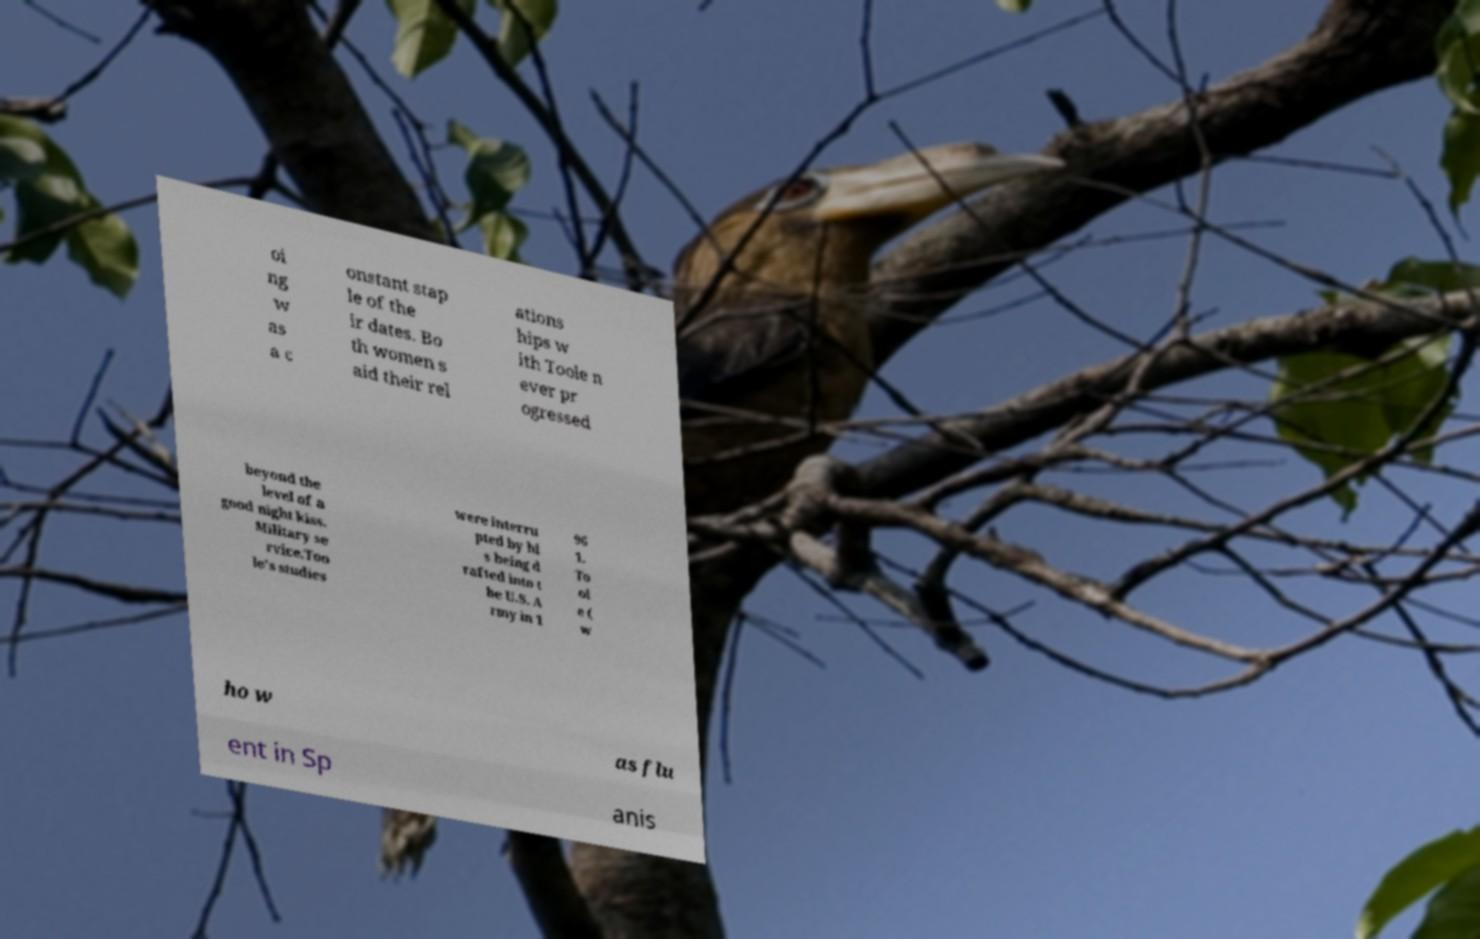There's text embedded in this image that I need extracted. Can you transcribe it verbatim? oi ng w as a c onstant stap le of the ir dates. Bo th women s aid their rel ations hips w ith Toole n ever pr ogressed beyond the level of a good night kiss. Military se rvice.Too le's studies were interru pted by hi s being d rafted into t he U.S. A rmy in 1 96 1. To ol e ( w ho w as flu ent in Sp anis 